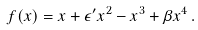Convert formula to latex. <formula><loc_0><loc_0><loc_500><loc_500>f ( x ) = x + \epsilon ^ { \prime } x ^ { 2 } - x ^ { 3 } + \beta x ^ { 4 } \, .</formula> 